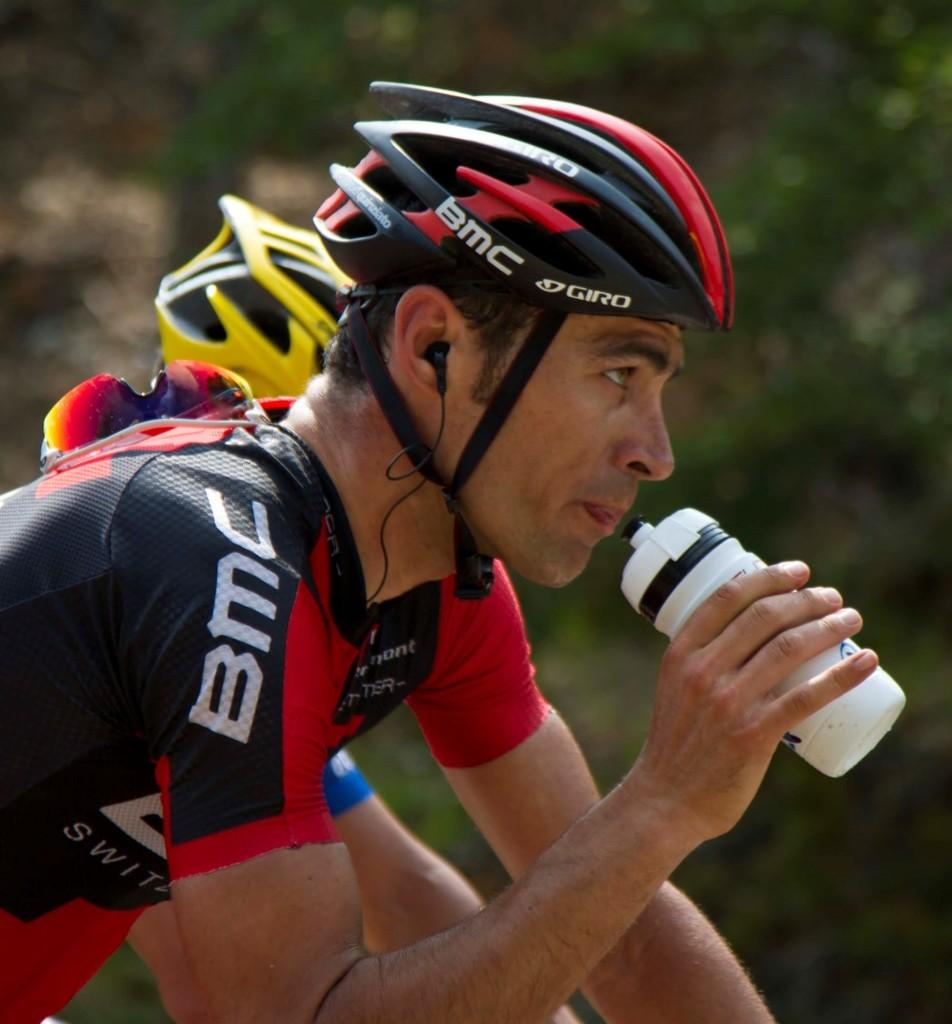How many people are in the image? There are two people in the image. What are the people wearing on their heads? Both people are wearing helmets. What is the man holding in his hand? The man is holding a bottle. What can be inferred about the man's gender? The person holding the bottle is likely a man. What protective gear is the man wearing? The man is wearing goggles and earphones. What can be seen in the background of the image? There are trees visible in the background of the image. How would you describe the background's appearance? The background is blurry. How many pies are being served on the back of the man in the image? There are no pies present in the image, and the man's back is not visible. What part of the man's body is being used to hold the bottle? The man is holding the bottle with his hand, not a specific part of his body. 